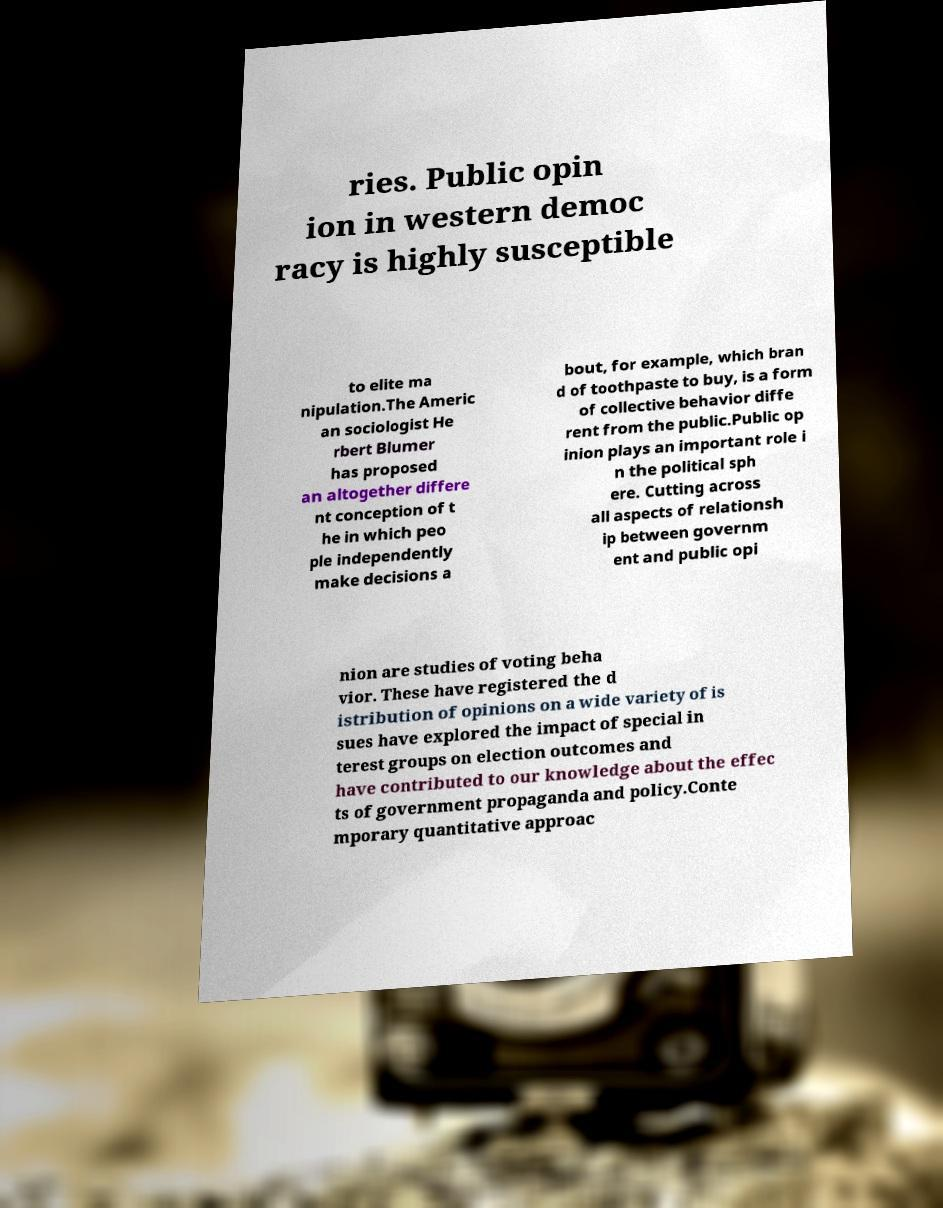Can you accurately transcribe the text from the provided image for me? ries. Public opin ion in western democ racy is highly susceptible to elite ma nipulation.The Americ an sociologist He rbert Blumer has proposed an altogether differe nt conception of t he in which peo ple independently make decisions a bout, for example, which bran d of toothpaste to buy, is a form of collective behavior diffe rent from the public.Public op inion plays an important role i n the political sph ere. Cutting across all aspects of relationsh ip between governm ent and public opi nion are studies of voting beha vior. These have registered the d istribution of opinions on a wide variety of is sues have explored the impact of special in terest groups on election outcomes and have contributed to our knowledge about the effec ts of government propaganda and policy.Conte mporary quantitative approac 